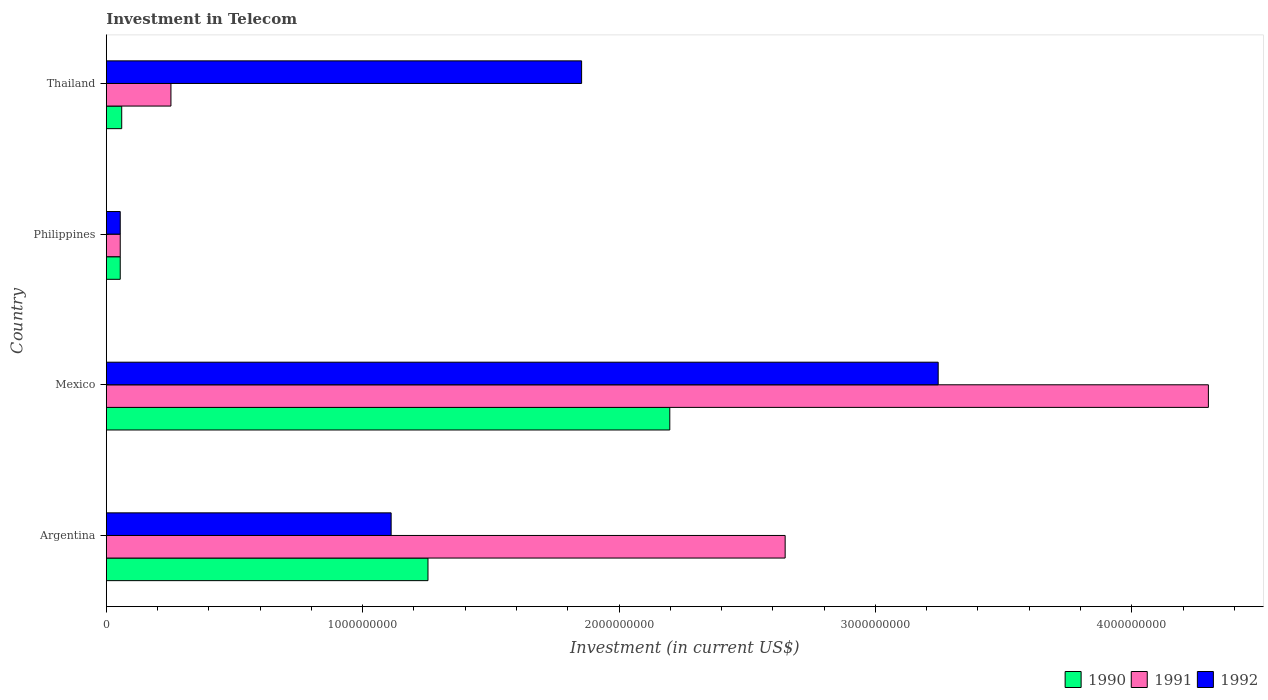Are the number of bars on each tick of the Y-axis equal?
Give a very brief answer. Yes. In how many cases, is the number of bars for a given country not equal to the number of legend labels?
Offer a terse response. 0. What is the amount invested in telecom in 1990 in Mexico?
Offer a terse response. 2.20e+09. Across all countries, what is the maximum amount invested in telecom in 1992?
Give a very brief answer. 3.24e+09. Across all countries, what is the minimum amount invested in telecom in 1990?
Ensure brevity in your answer.  5.42e+07. In which country was the amount invested in telecom in 1990 maximum?
Provide a short and direct response. Mexico. What is the total amount invested in telecom in 1990 in the graph?
Your response must be concise. 3.57e+09. What is the difference between the amount invested in telecom in 1992 in Argentina and that in Philippines?
Your response must be concise. 1.06e+09. What is the difference between the amount invested in telecom in 1990 in Argentina and the amount invested in telecom in 1991 in Thailand?
Ensure brevity in your answer.  1.00e+09. What is the average amount invested in telecom in 1991 per country?
Provide a succinct answer. 1.81e+09. What is the difference between the amount invested in telecom in 1992 and amount invested in telecom in 1990 in Thailand?
Offer a terse response. 1.79e+09. In how many countries, is the amount invested in telecom in 1990 greater than 3400000000 US$?
Give a very brief answer. 0. What is the ratio of the amount invested in telecom in 1991 in Argentina to that in Thailand?
Provide a succinct answer. 10.51. Is the amount invested in telecom in 1992 in Argentina less than that in Philippines?
Your answer should be compact. No. What is the difference between the highest and the second highest amount invested in telecom in 1992?
Offer a terse response. 1.39e+09. What is the difference between the highest and the lowest amount invested in telecom in 1990?
Provide a succinct answer. 2.14e+09. Is the sum of the amount invested in telecom in 1990 in Mexico and Thailand greater than the maximum amount invested in telecom in 1992 across all countries?
Provide a short and direct response. No. What does the 3rd bar from the bottom in Thailand represents?
Your response must be concise. 1992. Is it the case that in every country, the sum of the amount invested in telecom in 1990 and amount invested in telecom in 1991 is greater than the amount invested in telecom in 1992?
Offer a terse response. No. How many bars are there?
Keep it short and to the point. 12. What is the difference between two consecutive major ticks on the X-axis?
Make the answer very short. 1.00e+09. Does the graph contain grids?
Your response must be concise. No. Where does the legend appear in the graph?
Offer a very short reply. Bottom right. How many legend labels are there?
Your answer should be compact. 3. What is the title of the graph?
Keep it short and to the point. Investment in Telecom. Does "2009" appear as one of the legend labels in the graph?
Give a very brief answer. No. What is the label or title of the X-axis?
Provide a short and direct response. Investment (in current US$). What is the Investment (in current US$) in 1990 in Argentina?
Give a very brief answer. 1.25e+09. What is the Investment (in current US$) in 1991 in Argentina?
Offer a very short reply. 2.65e+09. What is the Investment (in current US$) of 1992 in Argentina?
Keep it short and to the point. 1.11e+09. What is the Investment (in current US$) of 1990 in Mexico?
Your answer should be compact. 2.20e+09. What is the Investment (in current US$) of 1991 in Mexico?
Your answer should be very brief. 4.30e+09. What is the Investment (in current US$) of 1992 in Mexico?
Offer a terse response. 3.24e+09. What is the Investment (in current US$) of 1990 in Philippines?
Offer a very short reply. 5.42e+07. What is the Investment (in current US$) of 1991 in Philippines?
Provide a succinct answer. 5.42e+07. What is the Investment (in current US$) in 1992 in Philippines?
Make the answer very short. 5.42e+07. What is the Investment (in current US$) of 1990 in Thailand?
Your answer should be very brief. 6.00e+07. What is the Investment (in current US$) in 1991 in Thailand?
Give a very brief answer. 2.52e+08. What is the Investment (in current US$) of 1992 in Thailand?
Your response must be concise. 1.85e+09. Across all countries, what is the maximum Investment (in current US$) in 1990?
Ensure brevity in your answer.  2.20e+09. Across all countries, what is the maximum Investment (in current US$) of 1991?
Offer a very short reply. 4.30e+09. Across all countries, what is the maximum Investment (in current US$) in 1992?
Keep it short and to the point. 3.24e+09. Across all countries, what is the minimum Investment (in current US$) of 1990?
Provide a succinct answer. 5.42e+07. Across all countries, what is the minimum Investment (in current US$) in 1991?
Your answer should be very brief. 5.42e+07. Across all countries, what is the minimum Investment (in current US$) in 1992?
Offer a terse response. 5.42e+07. What is the total Investment (in current US$) in 1990 in the graph?
Ensure brevity in your answer.  3.57e+09. What is the total Investment (in current US$) of 1991 in the graph?
Ensure brevity in your answer.  7.25e+09. What is the total Investment (in current US$) in 1992 in the graph?
Ensure brevity in your answer.  6.26e+09. What is the difference between the Investment (in current US$) in 1990 in Argentina and that in Mexico?
Provide a succinct answer. -9.43e+08. What is the difference between the Investment (in current US$) of 1991 in Argentina and that in Mexico?
Ensure brevity in your answer.  -1.65e+09. What is the difference between the Investment (in current US$) of 1992 in Argentina and that in Mexico?
Offer a terse response. -2.13e+09. What is the difference between the Investment (in current US$) in 1990 in Argentina and that in Philippines?
Provide a succinct answer. 1.20e+09. What is the difference between the Investment (in current US$) in 1991 in Argentina and that in Philippines?
Your response must be concise. 2.59e+09. What is the difference between the Investment (in current US$) in 1992 in Argentina and that in Philippines?
Ensure brevity in your answer.  1.06e+09. What is the difference between the Investment (in current US$) in 1990 in Argentina and that in Thailand?
Your answer should be compact. 1.19e+09. What is the difference between the Investment (in current US$) of 1991 in Argentina and that in Thailand?
Your answer should be very brief. 2.40e+09. What is the difference between the Investment (in current US$) of 1992 in Argentina and that in Thailand?
Give a very brief answer. -7.43e+08. What is the difference between the Investment (in current US$) of 1990 in Mexico and that in Philippines?
Ensure brevity in your answer.  2.14e+09. What is the difference between the Investment (in current US$) in 1991 in Mexico and that in Philippines?
Your response must be concise. 4.24e+09. What is the difference between the Investment (in current US$) of 1992 in Mexico and that in Philippines?
Your response must be concise. 3.19e+09. What is the difference between the Investment (in current US$) of 1990 in Mexico and that in Thailand?
Ensure brevity in your answer.  2.14e+09. What is the difference between the Investment (in current US$) in 1991 in Mexico and that in Thailand?
Your answer should be very brief. 4.05e+09. What is the difference between the Investment (in current US$) of 1992 in Mexico and that in Thailand?
Provide a succinct answer. 1.39e+09. What is the difference between the Investment (in current US$) of 1990 in Philippines and that in Thailand?
Keep it short and to the point. -5.80e+06. What is the difference between the Investment (in current US$) of 1991 in Philippines and that in Thailand?
Your response must be concise. -1.98e+08. What is the difference between the Investment (in current US$) in 1992 in Philippines and that in Thailand?
Provide a succinct answer. -1.80e+09. What is the difference between the Investment (in current US$) in 1990 in Argentina and the Investment (in current US$) in 1991 in Mexico?
Give a very brief answer. -3.04e+09. What is the difference between the Investment (in current US$) of 1990 in Argentina and the Investment (in current US$) of 1992 in Mexico?
Provide a short and direct response. -1.99e+09. What is the difference between the Investment (in current US$) in 1991 in Argentina and the Investment (in current US$) in 1992 in Mexico?
Offer a very short reply. -5.97e+08. What is the difference between the Investment (in current US$) in 1990 in Argentina and the Investment (in current US$) in 1991 in Philippines?
Offer a terse response. 1.20e+09. What is the difference between the Investment (in current US$) of 1990 in Argentina and the Investment (in current US$) of 1992 in Philippines?
Give a very brief answer. 1.20e+09. What is the difference between the Investment (in current US$) of 1991 in Argentina and the Investment (in current US$) of 1992 in Philippines?
Ensure brevity in your answer.  2.59e+09. What is the difference between the Investment (in current US$) in 1990 in Argentina and the Investment (in current US$) in 1991 in Thailand?
Ensure brevity in your answer.  1.00e+09. What is the difference between the Investment (in current US$) in 1990 in Argentina and the Investment (in current US$) in 1992 in Thailand?
Offer a terse response. -5.99e+08. What is the difference between the Investment (in current US$) in 1991 in Argentina and the Investment (in current US$) in 1992 in Thailand?
Give a very brief answer. 7.94e+08. What is the difference between the Investment (in current US$) in 1990 in Mexico and the Investment (in current US$) in 1991 in Philippines?
Give a very brief answer. 2.14e+09. What is the difference between the Investment (in current US$) in 1990 in Mexico and the Investment (in current US$) in 1992 in Philippines?
Provide a succinct answer. 2.14e+09. What is the difference between the Investment (in current US$) in 1991 in Mexico and the Investment (in current US$) in 1992 in Philippines?
Make the answer very short. 4.24e+09. What is the difference between the Investment (in current US$) of 1990 in Mexico and the Investment (in current US$) of 1991 in Thailand?
Provide a succinct answer. 1.95e+09. What is the difference between the Investment (in current US$) of 1990 in Mexico and the Investment (in current US$) of 1992 in Thailand?
Your response must be concise. 3.44e+08. What is the difference between the Investment (in current US$) in 1991 in Mexico and the Investment (in current US$) in 1992 in Thailand?
Ensure brevity in your answer.  2.44e+09. What is the difference between the Investment (in current US$) in 1990 in Philippines and the Investment (in current US$) in 1991 in Thailand?
Keep it short and to the point. -1.98e+08. What is the difference between the Investment (in current US$) in 1990 in Philippines and the Investment (in current US$) in 1992 in Thailand?
Provide a short and direct response. -1.80e+09. What is the difference between the Investment (in current US$) of 1991 in Philippines and the Investment (in current US$) of 1992 in Thailand?
Offer a very short reply. -1.80e+09. What is the average Investment (in current US$) in 1990 per country?
Your answer should be compact. 8.92e+08. What is the average Investment (in current US$) of 1991 per country?
Your answer should be compact. 1.81e+09. What is the average Investment (in current US$) in 1992 per country?
Make the answer very short. 1.57e+09. What is the difference between the Investment (in current US$) of 1990 and Investment (in current US$) of 1991 in Argentina?
Give a very brief answer. -1.39e+09. What is the difference between the Investment (in current US$) of 1990 and Investment (in current US$) of 1992 in Argentina?
Offer a terse response. 1.44e+08. What is the difference between the Investment (in current US$) in 1991 and Investment (in current US$) in 1992 in Argentina?
Ensure brevity in your answer.  1.54e+09. What is the difference between the Investment (in current US$) in 1990 and Investment (in current US$) in 1991 in Mexico?
Ensure brevity in your answer.  -2.10e+09. What is the difference between the Investment (in current US$) of 1990 and Investment (in current US$) of 1992 in Mexico?
Ensure brevity in your answer.  -1.05e+09. What is the difference between the Investment (in current US$) in 1991 and Investment (in current US$) in 1992 in Mexico?
Ensure brevity in your answer.  1.05e+09. What is the difference between the Investment (in current US$) in 1990 and Investment (in current US$) in 1991 in Thailand?
Your answer should be very brief. -1.92e+08. What is the difference between the Investment (in current US$) of 1990 and Investment (in current US$) of 1992 in Thailand?
Your answer should be very brief. -1.79e+09. What is the difference between the Investment (in current US$) of 1991 and Investment (in current US$) of 1992 in Thailand?
Provide a short and direct response. -1.60e+09. What is the ratio of the Investment (in current US$) in 1990 in Argentina to that in Mexico?
Your answer should be very brief. 0.57. What is the ratio of the Investment (in current US$) in 1991 in Argentina to that in Mexico?
Your answer should be very brief. 0.62. What is the ratio of the Investment (in current US$) in 1992 in Argentina to that in Mexico?
Provide a short and direct response. 0.34. What is the ratio of the Investment (in current US$) of 1990 in Argentina to that in Philippines?
Ensure brevity in your answer.  23.15. What is the ratio of the Investment (in current US$) in 1991 in Argentina to that in Philippines?
Provide a short and direct response. 48.86. What is the ratio of the Investment (in current US$) in 1992 in Argentina to that in Philippines?
Ensure brevity in your answer.  20.5. What is the ratio of the Investment (in current US$) in 1990 in Argentina to that in Thailand?
Offer a terse response. 20.91. What is the ratio of the Investment (in current US$) in 1991 in Argentina to that in Thailand?
Keep it short and to the point. 10.51. What is the ratio of the Investment (in current US$) of 1992 in Argentina to that in Thailand?
Your response must be concise. 0.6. What is the ratio of the Investment (in current US$) of 1990 in Mexico to that in Philippines?
Give a very brief answer. 40.55. What is the ratio of the Investment (in current US$) in 1991 in Mexico to that in Philippines?
Keep it short and to the point. 79.32. What is the ratio of the Investment (in current US$) of 1992 in Mexico to that in Philippines?
Offer a terse response. 59.87. What is the ratio of the Investment (in current US$) of 1990 in Mexico to that in Thailand?
Your response must be concise. 36.63. What is the ratio of the Investment (in current US$) in 1991 in Mexico to that in Thailand?
Offer a terse response. 17.06. What is the ratio of the Investment (in current US$) of 1992 in Mexico to that in Thailand?
Make the answer very short. 1.75. What is the ratio of the Investment (in current US$) of 1990 in Philippines to that in Thailand?
Your answer should be very brief. 0.9. What is the ratio of the Investment (in current US$) in 1991 in Philippines to that in Thailand?
Offer a terse response. 0.22. What is the ratio of the Investment (in current US$) in 1992 in Philippines to that in Thailand?
Offer a terse response. 0.03. What is the difference between the highest and the second highest Investment (in current US$) in 1990?
Give a very brief answer. 9.43e+08. What is the difference between the highest and the second highest Investment (in current US$) of 1991?
Provide a succinct answer. 1.65e+09. What is the difference between the highest and the second highest Investment (in current US$) in 1992?
Keep it short and to the point. 1.39e+09. What is the difference between the highest and the lowest Investment (in current US$) in 1990?
Provide a succinct answer. 2.14e+09. What is the difference between the highest and the lowest Investment (in current US$) in 1991?
Ensure brevity in your answer.  4.24e+09. What is the difference between the highest and the lowest Investment (in current US$) of 1992?
Provide a short and direct response. 3.19e+09. 